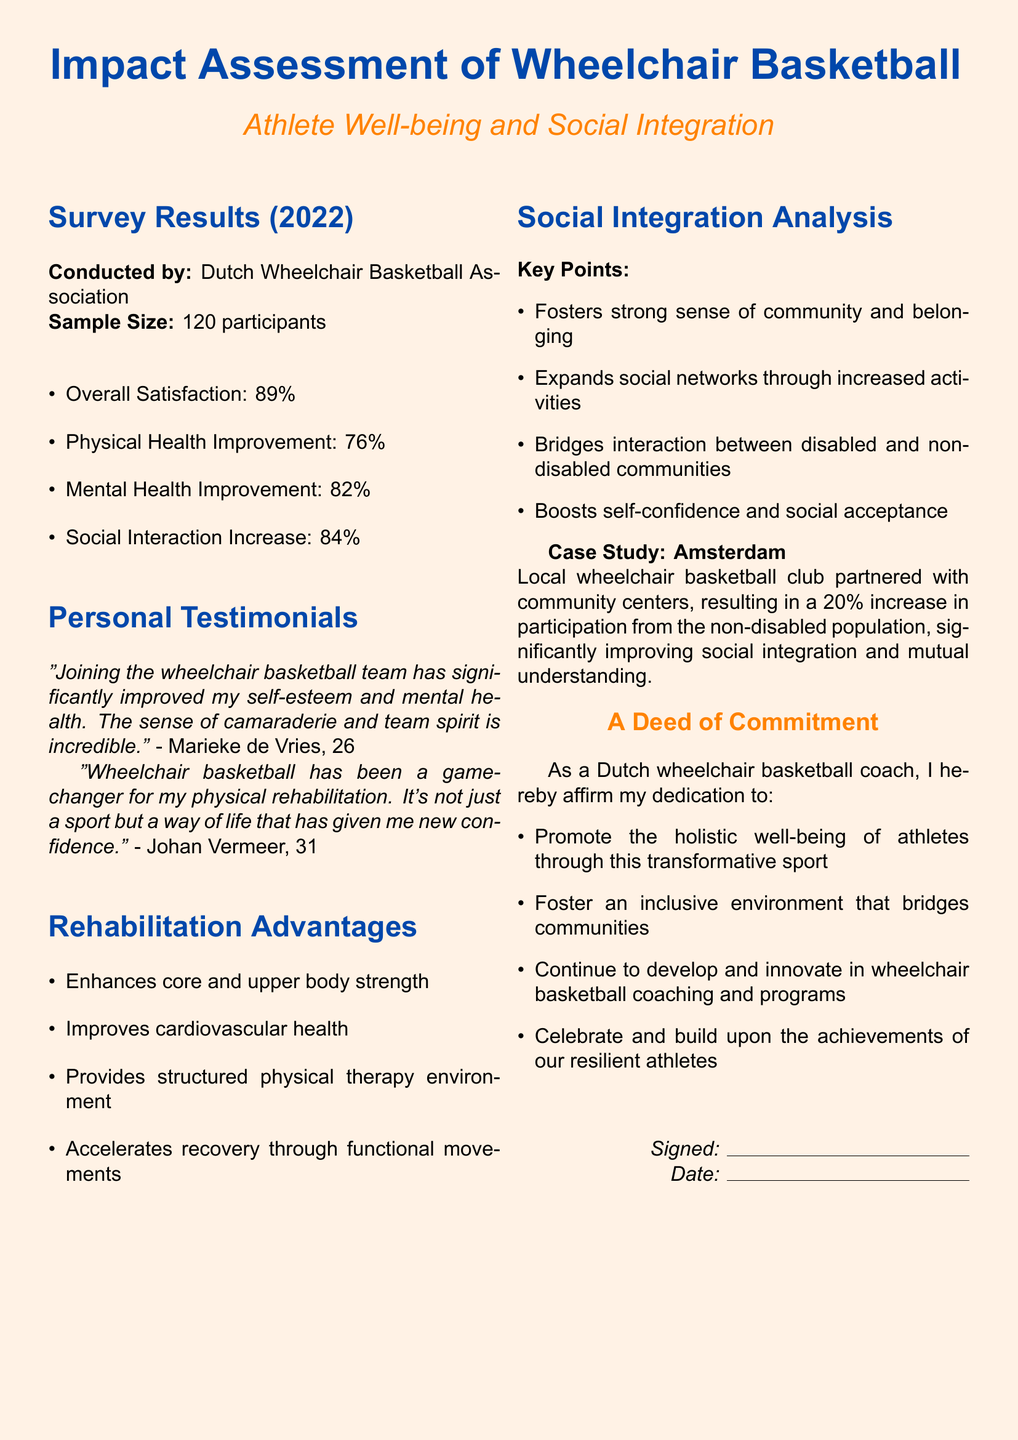what is the overall satisfaction percentage from the survey? The overall satisfaction percentage is explicitly stated in the survey results section of the document.
Answer: 89% how many participants were involved in the survey? The document specifies the sample size of the survey conducted.
Answer: 120 participants who provided a testimonial about improved mental health? The document quotes Marieke de Vries in relation to mental health improvement.
Answer: Marieke de Vries what percentage of participants noted an increase in social interaction? This information is found in the survey results section, highlighting social interaction specifically.
Answer: 84% what are the two main improvements mentioned for physical health benefits? By reviewing the rehabilitation advantages and survey results, we can identify key benefits.
Answer: Core and upper body strength why is wheelchair basketball considered a game-changer for rehabilitation? The document describes how wheelchair basketball serves as a means of rehabilitation and improvement in confidence.
Answer: It's not just a sport but a way of life that has given me new confidence what case study is mentioned in the social integration analysis? The social integration analysis section includes a specific case study to illustrate its points.
Answer: Amsterdam how did local wheelchair basketball clubs affect non-disabled population participation? The document outlines the impact of local clubs on community involvement, explicitly stating the result.
Answer: 20% increase in participation 